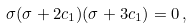<formula> <loc_0><loc_0><loc_500><loc_500>\sigma ( \sigma + 2 c _ { 1 } ) ( \sigma + 3 c _ { 1 } ) = 0 \, ,</formula> 